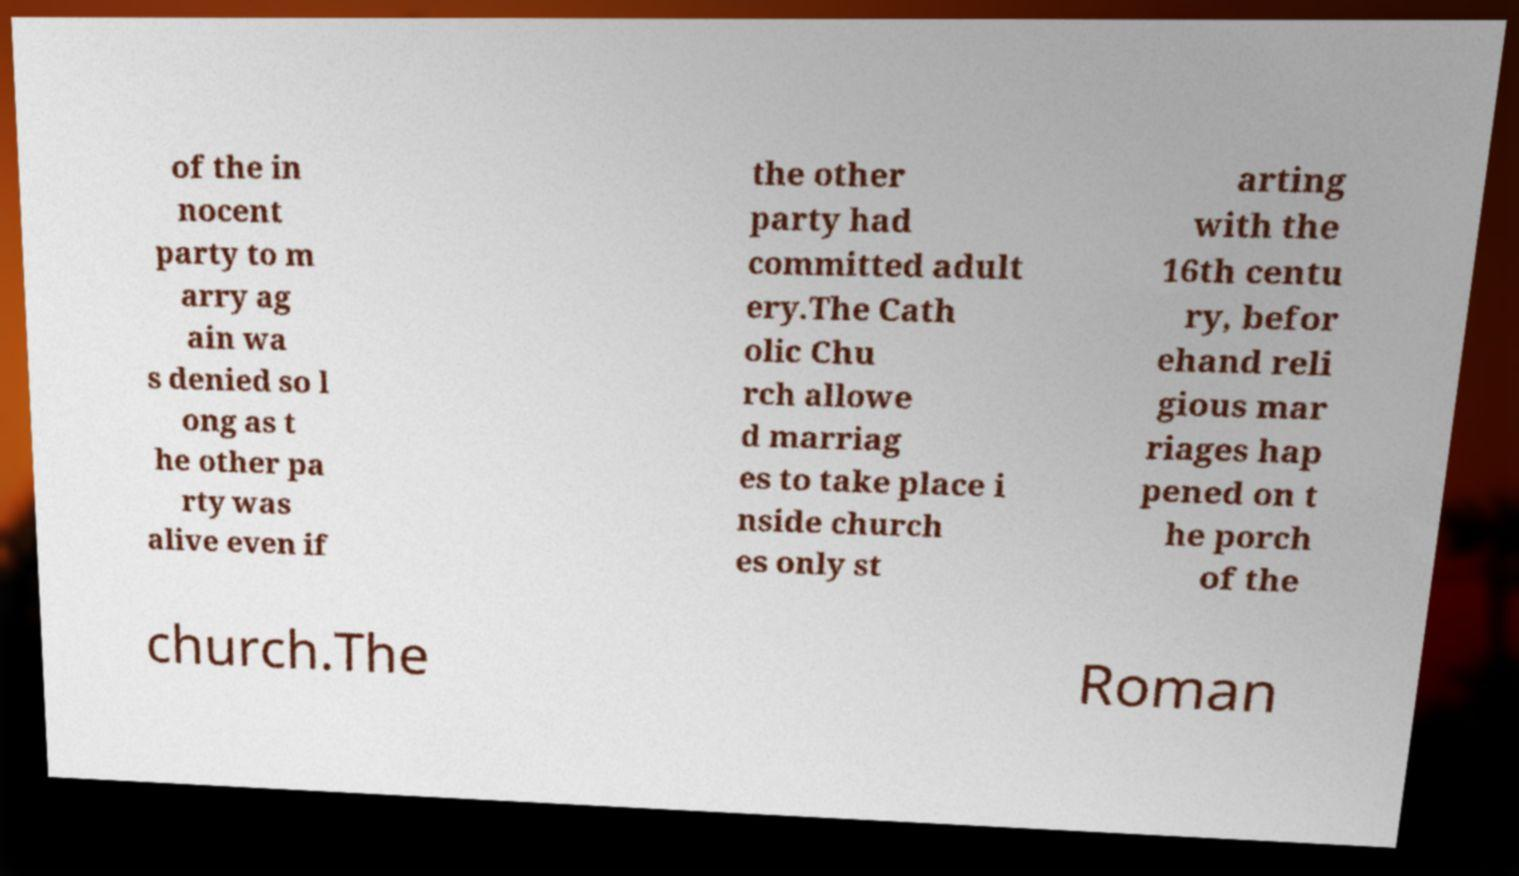I need the written content from this picture converted into text. Can you do that? of the in nocent party to m arry ag ain wa s denied so l ong as t he other pa rty was alive even if the other party had committed adult ery.The Cath olic Chu rch allowe d marriag es to take place i nside church es only st arting with the 16th centu ry, befor ehand reli gious mar riages hap pened on t he porch of the church.The Roman 